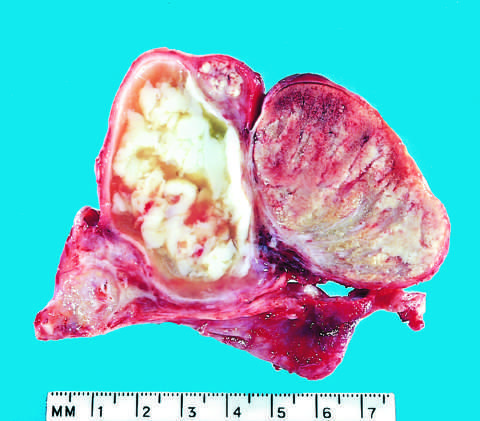how is acute epididymitis caused?
Answer the question using a single word or phrase. By gonococcal infection 